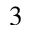Convert formula to latex. <formula><loc_0><loc_0><loc_500><loc_500>3</formula> 